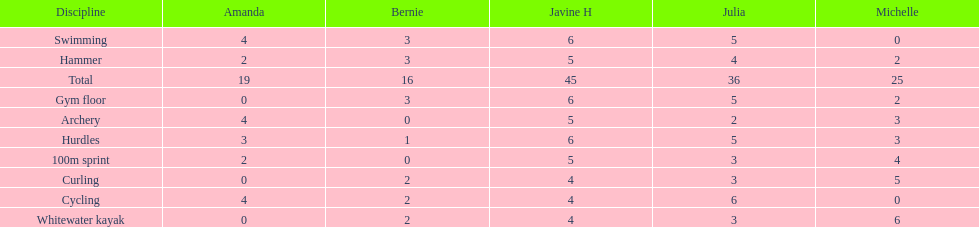Who had her best score in cycling? Julia. 